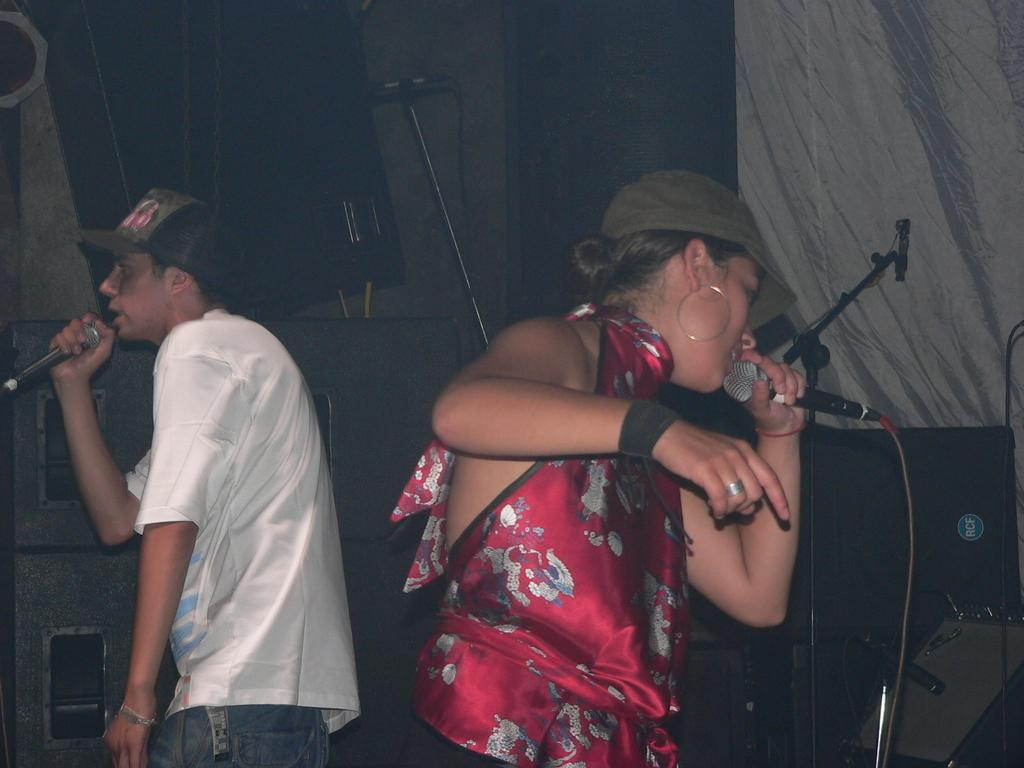Who is present in the image? There is a man and a woman in the image. What are the man and woman doing in the image? Both the man and woman are singing in the image. How are they amplifying their voices? They are using a microphone in the image. Where are they performing? They are on a dais in the image. What type of office furniture can be seen in the image? There is no office furniture present in the image. What type of mass is being performed in the image? There is no mass being performed in the image; the man and woman are singing. 